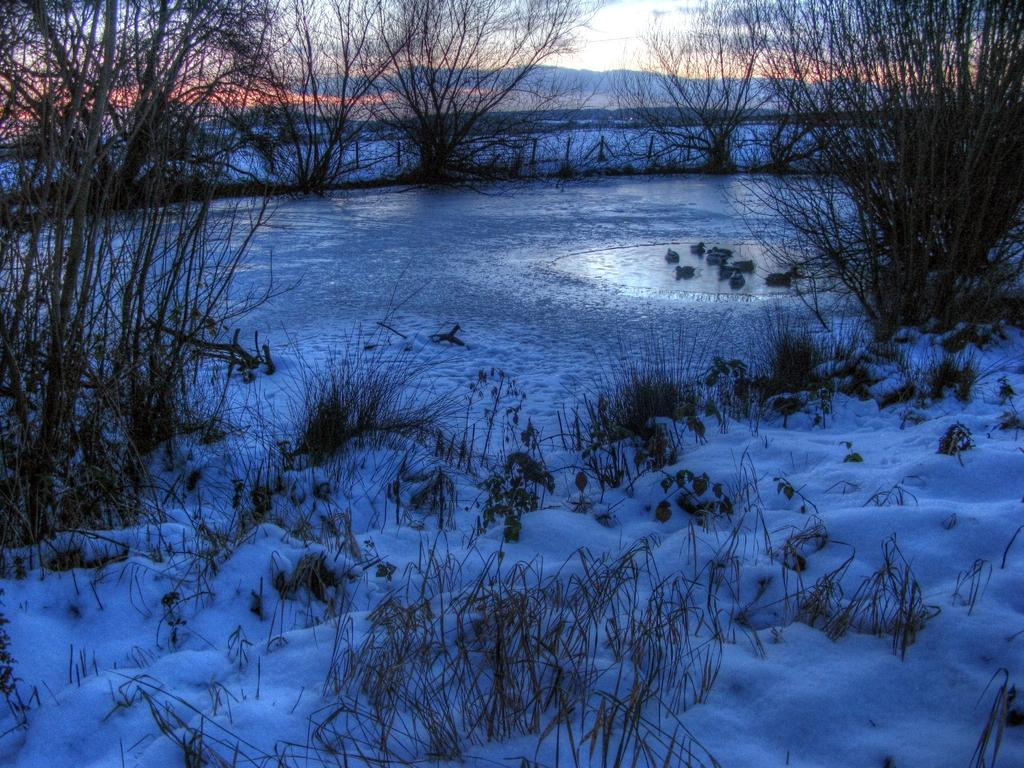What type of natural environment is depicted at the bottom of the image? There is snow at the bottom of the image. What type of vegetation can be seen growing in the snow? A: There is grass in the snow. What can be seen in the background of the image? There are trees in the background of the image. What is visible at the top of the image? The sky is visible at the top of the image. What type of body of water is present in the middle of the image? There is water in the middle of the image. How many sisters are playing in the water in the image? There are no sisters present in the image; it features snow, grass, trees, sky, and water. What type of riddle can be solved using the image? There is no riddle present in the image; it is a depiction of a natural environment with snow, grass, trees, sky, and water. 